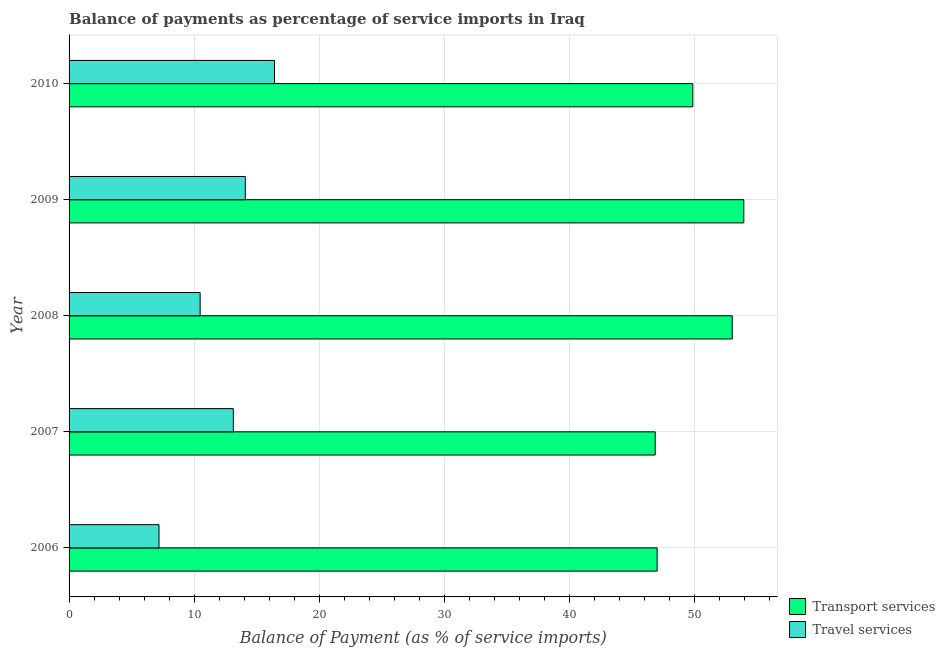How many groups of bars are there?
Make the answer very short. 5. Are the number of bars per tick equal to the number of legend labels?
Give a very brief answer. Yes. Are the number of bars on each tick of the Y-axis equal?
Offer a terse response. Yes. How many bars are there on the 2nd tick from the bottom?
Make the answer very short. 2. What is the balance of payments of transport services in 2009?
Make the answer very short. 53.95. Across all years, what is the maximum balance of payments of transport services?
Ensure brevity in your answer.  53.95. Across all years, what is the minimum balance of payments of travel services?
Your response must be concise. 7.19. What is the total balance of payments of transport services in the graph?
Your answer should be very brief. 250.73. What is the difference between the balance of payments of transport services in 2006 and that in 2009?
Make the answer very short. -6.93. What is the difference between the balance of payments of travel services in 2008 and the balance of payments of transport services in 2010?
Offer a terse response. -39.39. What is the average balance of payments of transport services per year?
Make the answer very short. 50.15. In the year 2010, what is the difference between the balance of payments of transport services and balance of payments of travel services?
Your answer should be very brief. 33.45. Is the balance of payments of travel services in 2006 less than that in 2009?
Ensure brevity in your answer.  Yes. Is the difference between the balance of payments of transport services in 2006 and 2009 greater than the difference between the balance of payments of travel services in 2006 and 2009?
Your response must be concise. No. What is the difference between the highest and the second highest balance of payments of travel services?
Provide a short and direct response. 2.33. What is the difference between the highest and the lowest balance of payments of transport services?
Your answer should be very brief. 7.08. In how many years, is the balance of payments of travel services greater than the average balance of payments of travel services taken over all years?
Provide a short and direct response. 3. What does the 1st bar from the top in 2008 represents?
Keep it short and to the point. Travel services. What does the 2nd bar from the bottom in 2006 represents?
Your response must be concise. Travel services. Are all the bars in the graph horizontal?
Keep it short and to the point. Yes. How many years are there in the graph?
Your answer should be compact. 5. What is the difference between two consecutive major ticks on the X-axis?
Your answer should be compact. 10. Where does the legend appear in the graph?
Make the answer very short. Bottom right. How are the legend labels stacked?
Offer a terse response. Vertical. What is the title of the graph?
Your answer should be very brief. Balance of payments as percentage of service imports in Iraq. What is the label or title of the X-axis?
Ensure brevity in your answer.  Balance of Payment (as % of service imports). What is the Balance of Payment (as % of service imports) in Transport services in 2006?
Offer a very short reply. 47.02. What is the Balance of Payment (as % of service imports) of Travel services in 2006?
Make the answer very short. 7.19. What is the Balance of Payment (as % of service imports) in Transport services in 2007?
Provide a short and direct response. 46.87. What is the Balance of Payment (as % of service imports) in Travel services in 2007?
Offer a terse response. 13.14. What is the Balance of Payment (as % of service imports) in Transport services in 2008?
Your answer should be compact. 53.03. What is the Balance of Payment (as % of service imports) of Travel services in 2008?
Give a very brief answer. 10.48. What is the Balance of Payment (as % of service imports) in Transport services in 2009?
Provide a short and direct response. 53.95. What is the Balance of Payment (as % of service imports) in Travel services in 2009?
Ensure brevity in your answer.  14.09. What is the Balance of Payment (as % of service imports) in Transport services in 2010?
Give a very brief answer. 49.87. What is the Balance of Payment (as % of service imports) in Travel services in 2010?
Ensure brevity in your answer.  16.42. Across all years, what is the maximum Balance of Payment (as % of service imports) of Transport services?
Your response must be concise. 53.95. Across all years, what is the maximum Balance of Payment (as % of service imports) of Travel services?
Make the answer very short. 16.42. Across all years, what is the minimum Balance of Payment (as % of service imports) in Transport services?
Offer a very short reply. 46.87. Across all years, what is the minimum Balance of Payment (as % of service imports) in Travel services?
Give a very brief answer. 7.19. What is the total Balance of Payment (as % of service imports) of Transport services in the graph?
Provide a short and direct response. 250.73. What is the total Balance of Payment (as % of service imports) of Travel services in the graph?
Ensure brevity in your answer.  61.32. What is the difference between the Balance of Payment (as % of service imports) in Transport services in 2006 and that in 2007?
Provide a succinct answer. 0.15. What is the difference between the Balance of Payment (as % of service imports) in Travel services in 2006 and that in 2007?
Offer a terse response. -5.94. What is the difference between the Balance of Payment (as % of service imports) in Transport services in 2006 and that in 2008?
Make the answer very short. -6.01. What is the difference between the Balance of Payment (as % of service imports) of Travel services in 2006 and that in 2008?
Make the answer very short. -3.29. What is the difference between the Balance of Payment (as % of service imports) of Transport services in 2006 and that in 2009?
Keep it short and to the point. -6.93. What is the difference between the Balance of Payment (as % of service imports) in Travel services in 2006 and that in 2009?
Provide a succinct answer. -6.9. What is the difference between the Balance of Payment (as % of service imports) in Transport services in 2006 and that in 2010?
Give a very brief answer. -2.85. What is the difference between the Balance of Payment (as % of service imports) of Travel services in 2006 and that in 2010?
Your response must be concise. -9.23. What is the difference between the Balance of Payment (as % of service imports) of Transport services in 2007 and that in 2008?
Your response must be concise. -6.16. What is the difference between the Balance of Payment (as % of service imports) of Travel services in 2007 and that in 2008?
Give a very brief answer. 2.66. What is the difference between the Balance of Payment (as % of service imports) of Transport services in 2007 and that in 2009?
Offer a very short reply. -7.08. What is the difference between the Balance of Payment (as % of service imports) of Travel services in 2007 and that in 2009?
Offer a terse response. -0.96. What is the difference between the Balance of Payment (as % of service imports) of Transport services in 2007 and that in 2010?
Keep it short and to the point. -3.01. What is the difference between the Balance of Payment (as % of service imports) of Travel services in 2007 and that in 2010?
Your answer should be compact. -3.29. What is the difference between the Balance of Payment (as % of service imports) of Transport services in 2008 and that in 2009?
Your response must be concise. -0.92. What is the difference between the Balance of Payment (as % of service imports) of Travel services in 2008 and that in 2009?
Offer a very short reply. -3.61. What is the difference between the Balance of Payment (as % of service imports) of Transport services in 2008 and that in 2010?
Keep it short and to the point. 3.15. What is the difference between the Balance of Payment (as % of service imports) of Travel services in 2008 and that in 2010?
Provide a succinct answer. -5.94. What is the difference between the Balance of Payment (as % of service imports) in Transport services in 2009 and that in 2010?
Your answer should be very brief. 4.08. What is the difference between the Balance of Payment (as % of service imports) in Travel services in 2009 and that in 2010?
Your response must be concise. -2.33. What is the difference between the Balance of Payment (as % of service imports) of Transport services in 2006 and the Balance of Payment (as % of service imports) of Travel services in 2007?
Your response must be concise. 33.88. What is the difference between the Balance of Payment (as % of service imports) of Transport services in 2006 and the Balance of Payment (as % of service imports) of Travel services in 2008?
Your answer should be very brief. 36.54. What is the difference between the Balance of Payment (as % of service imports) of Transport services in 2006 and the Balance of Payment (as % of service imports) of Travel services in 2009?
Offer a very short reply. 32.93. What is the difference between the Balance of Payment (as % of service imports) of Transport services in 2006 and the Balance of Payment (as % of service imports) of Travel services in 2010?
Make the answer very short. 30.6. What is the difference between the Balance of Payment (as % of service imports) in Transport services in 2007 and the Balance of Payment (as % of service imports) in Travel services in 2008?
Your answer should be very brief. 36.39. What is the difference between the Balance of Payment (as % of service imports) of Transport services in 2007 and the Balance of Payment (as % of service imports) of Travel services in 2009?
Offer a terse response. 32.77. What is the difference between the Balance of Payment (as % of service imports) in Transport services in 2007 and the Balance of Payment (as % of service imports) in Travel services in 2010?
Your answer should be very brief. 30.44. What is the difference between the Balance of Payment (as % of service imports) of Transport services in 2008 and the Balance of Payment (as % of service imports) of Travel services in 2009?
Give a very brief answer. 38.93. What is the difference between the Balance of Payment (as % of service imports) in Transport services in 2008 and the Balance of Payment (as % of service imports) in Travel services in 2010?
Ensure brevity in your answer.  36.6. What is the difference between the Balance of Payment (as % of service imports) in Transport services in 2009 and the Balance of Payment (as % of service imports) in Travel services in 2010?
Provide a short and direct response. 37.52. What is the average Balance of Payment (as % of service imports) of Transport services per year?
Offer a very short reply. 50.15. What is the average Balance of Payment (as % of service imports) of Travel services per year?
Provide a succinct answer. 12.26. In the year 2006, what is the difference between the Balance of Payment (as % of service imports) of Transport services and Balance of Payment (as % of service imports) of Travel services?
Your response must be concise. 39.83. In the year 2007, what is the difference between the Balance of Payment (as % of service imports) of Transport services and Balance of Payment (as % of service imports) of Travel services?
Provide a succinct answer. 33.73. In the year 2008, what is the difference between the Balance of Payment (as % of service imports) of Transport services and Balance of Payment (as % of service imports) of Travel services?
Give a very brief answer. 42.55. In the year 2009, what is the difference between the Balance of Payment (as % of service imports) of Transport services and Balance of Payment (as % of service imports) of Travel services?
Ensure brevity in your answer.  39.86. In the year 2010, what is the difference between the Balance of Payment (as % of service imports) in Transport services and Balance of Payment (as % of service imports) in Travel services?
Your answer should be compact. 33.45. What is the ratio of the Balance of Payment (as % of service imports) of Transport services in 2006 to that in 2007?
Provide a short and direct response. 1. What is the ratio of the Balance of Payment (as % of service imports) of Travel services in 2006 to that in 2007?
Keep it short and to the point. 0.55. What is the ratio of the Balance of Payment (as % of service imports) of Transport services in 2006 to that in 2008?
Provide a short and direct response. 0.89. What is the ratio of the Balance of Payment (as % of service imports) of Travel services in 2006 to that in 2008?
Offer a very short reply. 0.69. What is the ratio of the Balance of Payment (as % of service imports) of Transport services in 2006 to that in 2009?
Your answer should be very brief. 0.87. What is the ratio of the Balance of Payment (as % of service imports) of Travel services in 2006 to that in 2009?
Offer a terse response. 0.51. What is the ratio of the Balance of Payment (as % of service imports) of Transport services in 2006 to that in 2010?
Provide a short and direct response. 0.94. What is the ratio of the Balance of Payment (as % of service imports) in Travel services in 2006 to that in 2010?
Keep it short and to the point. 0.44. What is the ratio of the Balance of Payment (as % of service imports) of Transport services in 2007 to that in 2008?
Your answer should be compact. 0.88. What is the ratio of the Balance of Payment (as % of service imports) of Travel services in 2007 to that in 2008?
Offer a terse response. 1.25. What is the ratio of the Balance of Payment (as % of service imports) in Transport services in 2007 to that in 2009?
Keep it short and to the point. 0.87. What is the ratio of the Balance of Payment (as % of service imports) of Travel services in 2007 to that in 2009?
Ensure brevity in your answer.  0.93. What is the ratio of the Balance of Payment (as % of service imports) of Transport services in 2007 to that in 2010?
Keep it short and to the point. 0.94. What is the ratio of the Balance of Payment (as % of service imports) of Travel services in 2007 to that in 2010?
Your answer should be compact. 0.8. What is the ratio of the Balance of Payment (as % of service imports) of Transport services in 2008 to that in 2009?
Make the answer very short. 0.98. What is the ratio of the Balance of Payment (as % of service imports) of Travel services in 2008 to that in 2009?
Provide a short and direct response. 0.74. What is the ratio of the Balance of Payment (as % of service imports) of Transport services in 2008 to that in 2010?
Make the answer very short. 1.06. What is the ratio of the Balance of Payment (as % of service imports) in Travel services in 2008 to that in 2010?
Keep it short and to the point. 0.64. What is the ratio of the Balance of Payment (as % of service imports) in Transport services in 2009 to that in 2010?
Offer a very short reply. 1.08. What is the ratio of the Balance of Payment (as % of service imports) of Travel services in 2009 to that in 2010?
Keep it short and to the point. 0.86. What is the difference between the highest and the second highest Balance of Payment (as % of service imports) of Transport services?
Keep it short and to the point. 0.92. What is the difference between the highest and the second highest Balance of Payment (as % of service imports) of Travel services?
Make the answer very short. 2.33. What is the difference between the highest and the lowest Balance of Payment (as % of service imports) of Transport services?
Offer a very short reply. 7.08. What is the difference between the highest and the lowest Balance of Payment (as % of service imports) of Travel services?
Offer a very short reply. 9.23. 